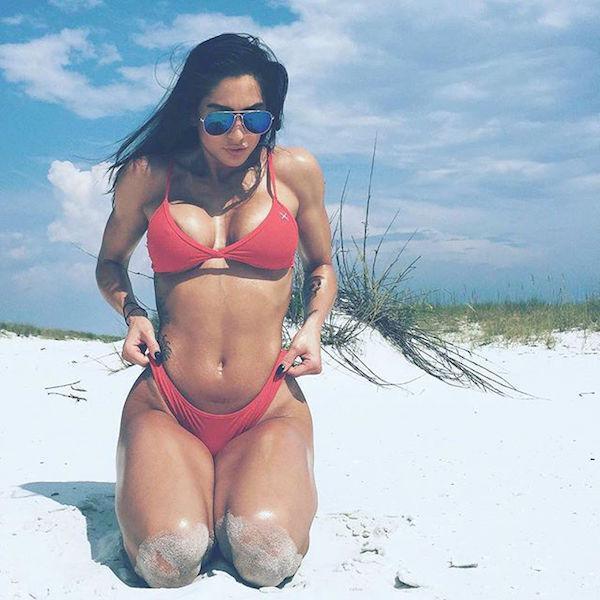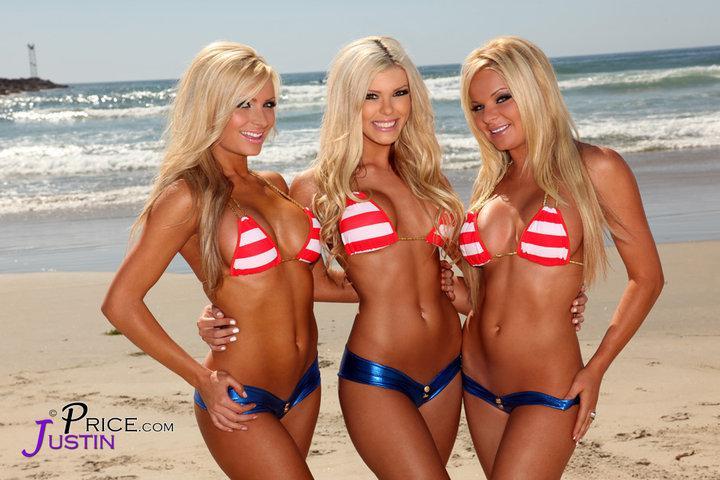The first image is the image on the left, the second image is the image on the right. Given the left and right images, does the statement "In the left image, a woman poses in a bikini on a sandy beach by herself" hold true? Answer yes or no. Yes. The first image is the image on the left, the second image is the image on the right. Considering the images on both sides, is "A striped bikini top is modeled in one image." valid? Answer yes or no. Yes. 